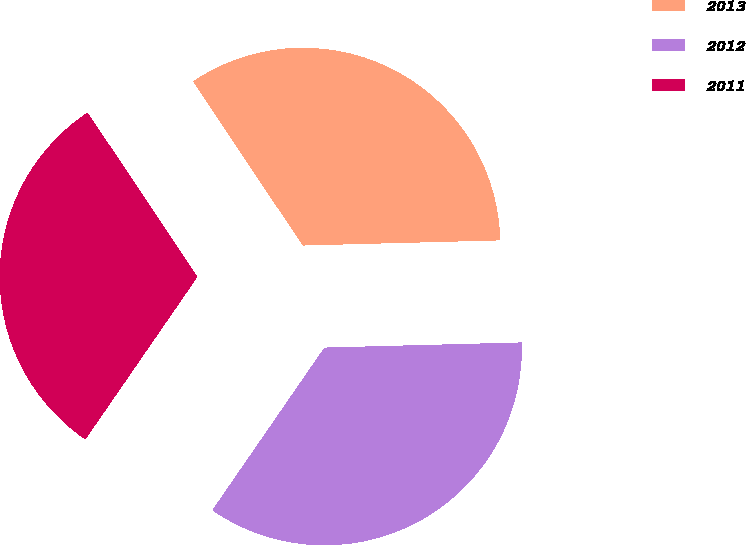Convert chart to OTSL. <chart><loc_0><loc_0><loc_500><loc_500><pie_chart><fcel>2013<fcel>2012<fcel>2011<nl><fcel>33.97%<fcel>35.02%<fcel>31.01%<nl></chart> 